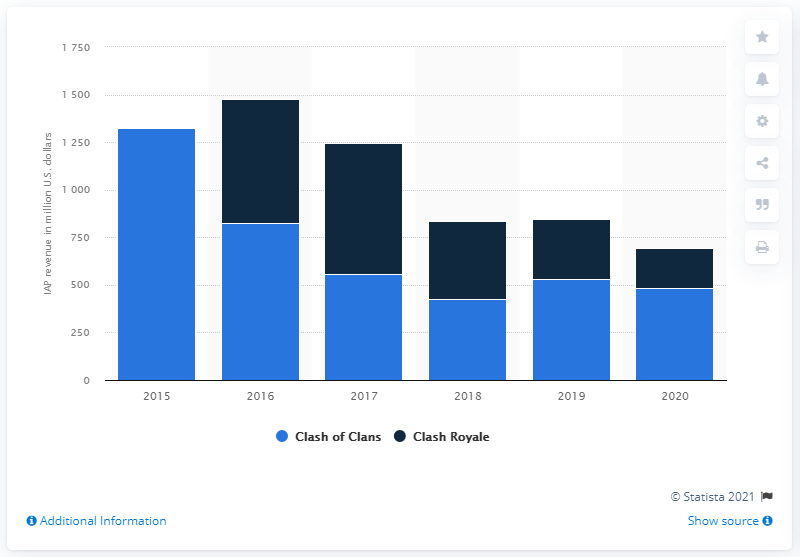Outline some significant characteristics in this image. Clash Royale generated approximately 209.36 million U.S. dollars in in-app purchases (IAP) revenues in the United States. In 2020, the mobile strategy game Clash of Clans generated approximately 483.32 million U.S. dollars in revenue through in-app purchases. 